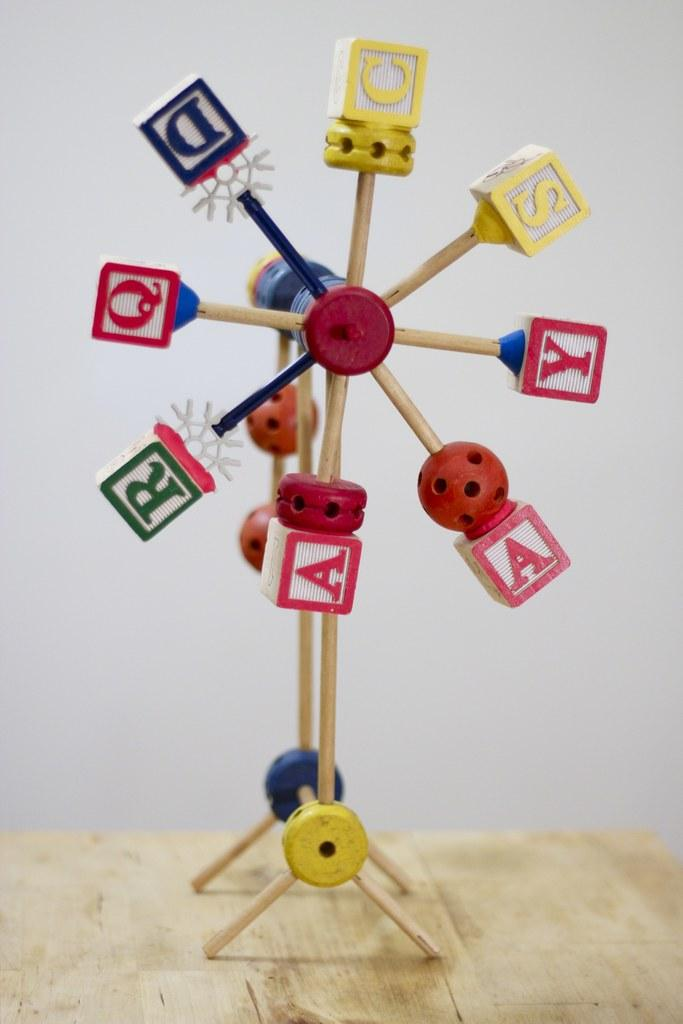What object in the image is designed for play? There is a toy in the image. What feature is present on the toy? The toy has letters on it. On what surface is the toy placed? The toy is on a wooden surface. What can be seen in the background of the image? There is a wall in the background of the image. What type of yak can be seen grazing on the wooden surface in the image? There is no yak present in the image; it features a toy with letters on a wooden surface. How many quarters can be seen on the toy in the image? There are no quarters present on the toy in the image. 